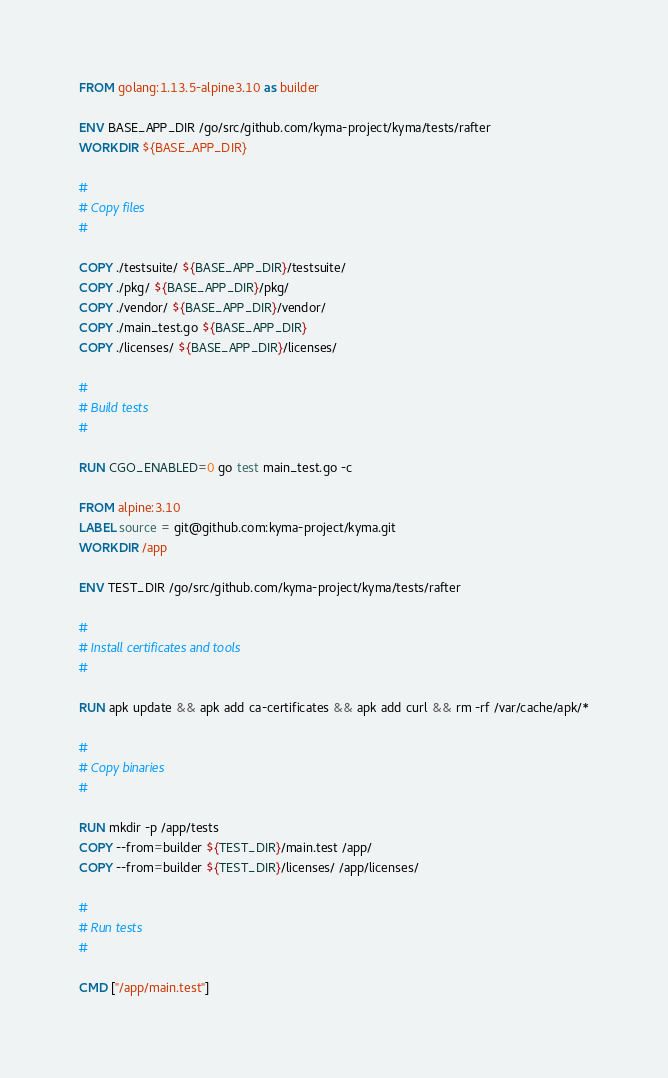<code> <loc_0><loc_0><loc_500><loc_500><_Dockerfile_>FROM golang:1.13.5-alpine3.10 as builder

ENV BASE_APP_DIR /go/src/github.com/kyma-project/kyma/tests/rafter
WORKDIR ${BASE_APP_DIR}

#
# Copy files
#

COPY ./testsuite/ ${BASE_APP_DIR}/testsuite/
COPY ./pkg/ ${BASE_APP_DIR}/pkg/
COPY ./vendor/ ${BASE_APP_DIR}/vendor/
COPY ./main_test.go ${BASE_APP_DIR}
COPY ./licenses/ ${BASE_APP_DIR}/licenses/

#
# Build tests
#

RUN CGO_ENABLED=0 go test main_test.go -c

FROM alpine:3.10
LABEL source = git@github.com:kyma-project/kyma.git
WORKDIR /app

ENV TEST_DIR /go/src/github.com/kyma-project/kyma/tests/rafter

#
# Install certificates and tools
#

RUN apk update && apk add ca-certificates && apk add curl && rm -rf /var/cache/apk/*

#
# Copy binaries
#

RUN mkdir -p /app/tests
COPY --from=builder ${TEST_DIR}/main.test /app/
COPY --from=builder ${TEST_DIR}/licenses/ /app/licenses/

#
# Run tests
#

CMD ["/app/main.test"]
</code> 